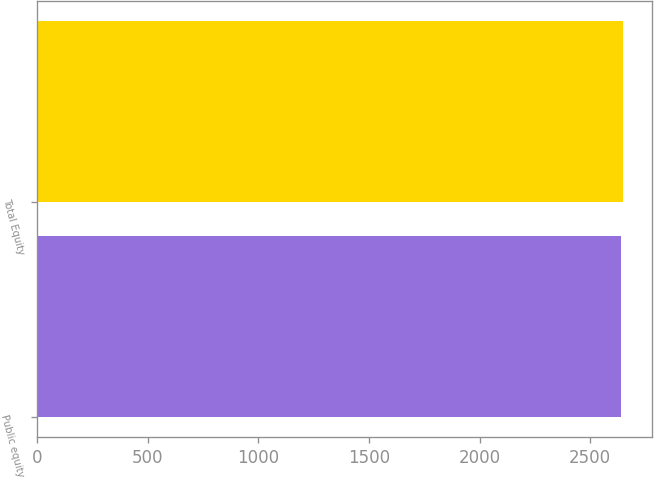Convert chart to OTSL. <chart><loc_0><loc_0><loc_500><loc_500><bar_chart><fcel>Public equity<fcel>Total Equity<nl><fcel>2638<fcel>2647<nl></chart> 